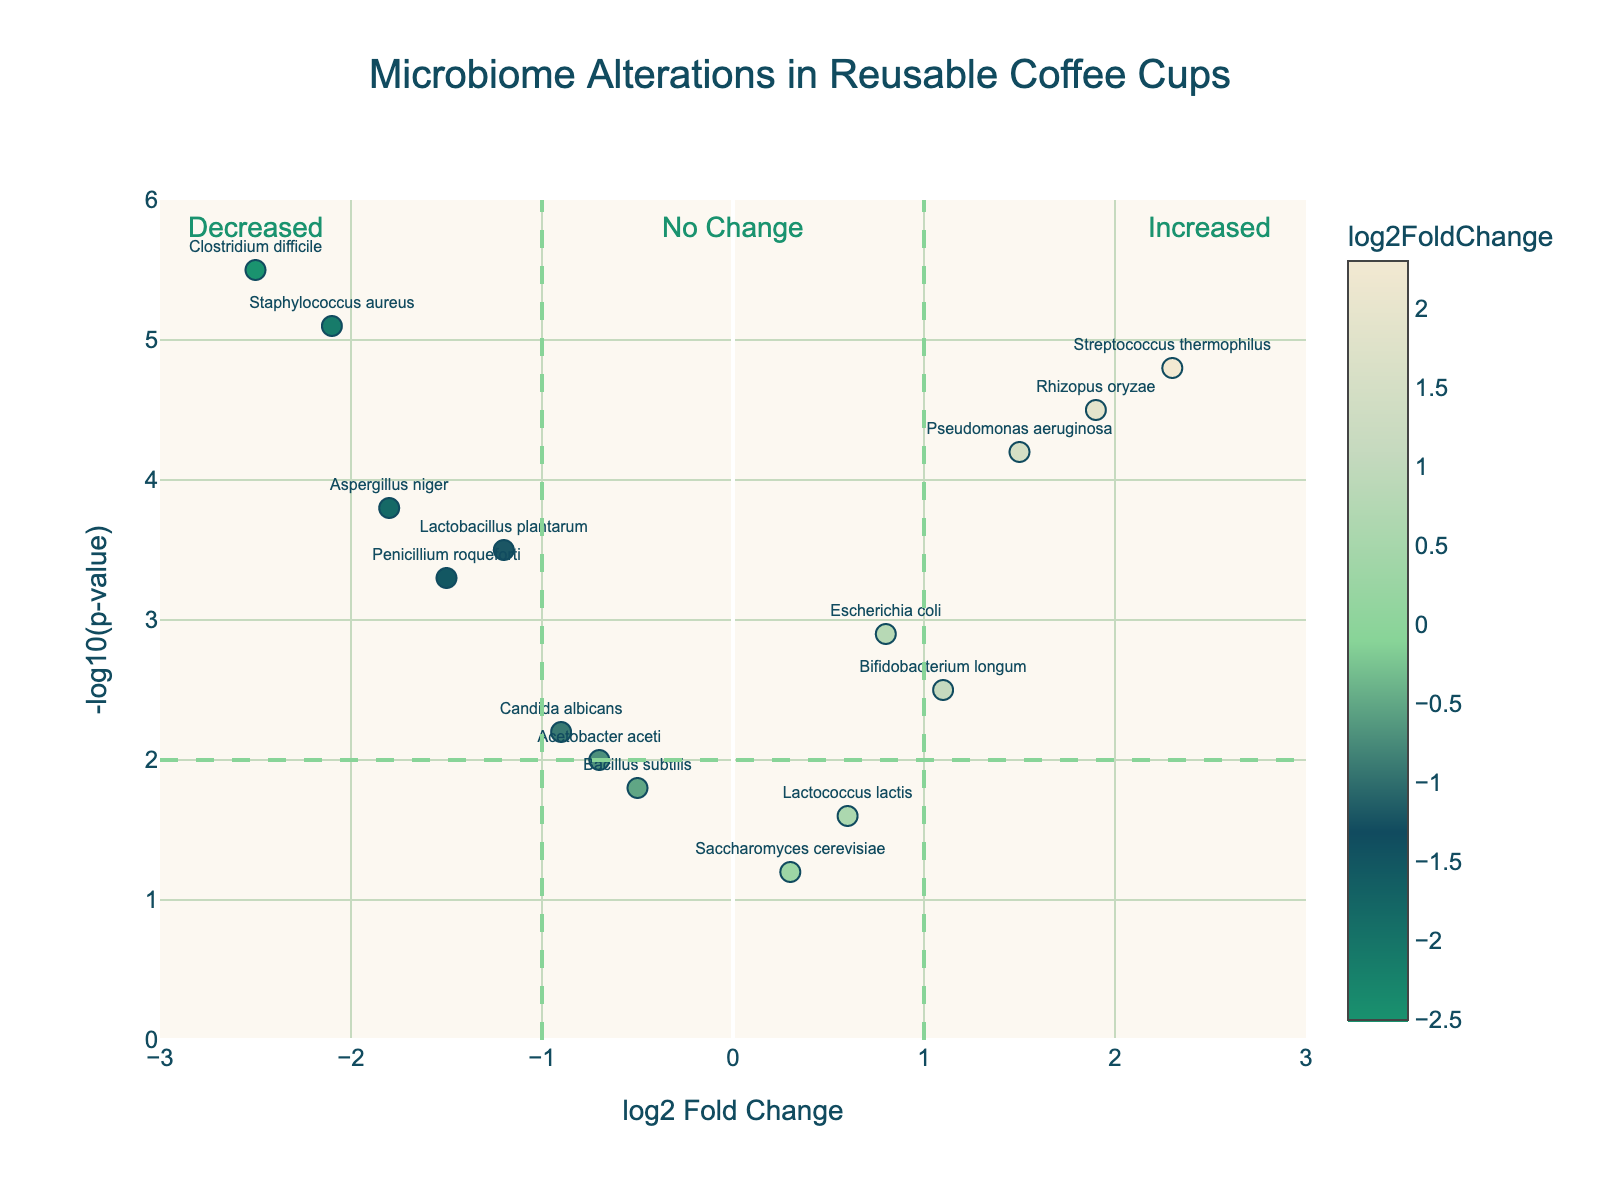What's the title of the figure? The title of the figure is written at the top center in larger font and a distinctive color.
Answer: Microbiome Alterations in Reusable Coffee Cups What are the axes labels in the figure? To identify what the plot visualizes on the x and y axes, we can look at the labels. The x-axis label is written horizontally below the axis and the y-axis label is written vertically to the left of the axis.
Answer: The x-axis is labeled "log2 Fold Change" and the y-axis is labeled "-log10(p-value)." How many microorganisms are annotated on the plot? We can count the number of data points marked with text in the figure, where each text corresponds to a microorganism name.
Answer: 15 Which microorganism shows the highest increase in log2FoldChange? To find this, look for the point farthest to the right on the x-axis, indicating the maximum log2FoldChange value, and read its label.
Answer: Streptococcus thermophilus Which microorganism has the most significant p-value? The microorganism with the highest -log10(p-value) is the most significant. Check for the point highest on the y-axis and read its label.
Answer: Clostridium difficile How many microorganisms have a log2FoldChange less than -1? Identify data points on the left side of the vertical line at -1 on the x-axis and count them.
Answer: 5 Which microorganism falls into the quadrant indicating a decreased log2FoldChange and high significance? This microorganism will be to the left of the vertical line at -1 and above the horizontal line at 2 on the plot.
Answer: Staphylococcus aureus What color represents a similar log2FoldChange to zero? Observing the colorscale bar, notice that the colors corresponding to a log2FoldChange near zero are identified by matching them with the central color on the colorscale.
Answer: A color blending toward the middle of the color scale Which microorganism has a higher significance - Escherichia coli or Pseudomonas aeruginosa? Compare the vertical positions of the points representing Escherichia coli and Pseudomonas aeruginosa. The higher the position on the y-axis, the more significant it is.
Answer: Pseudomonas aeruginosa 